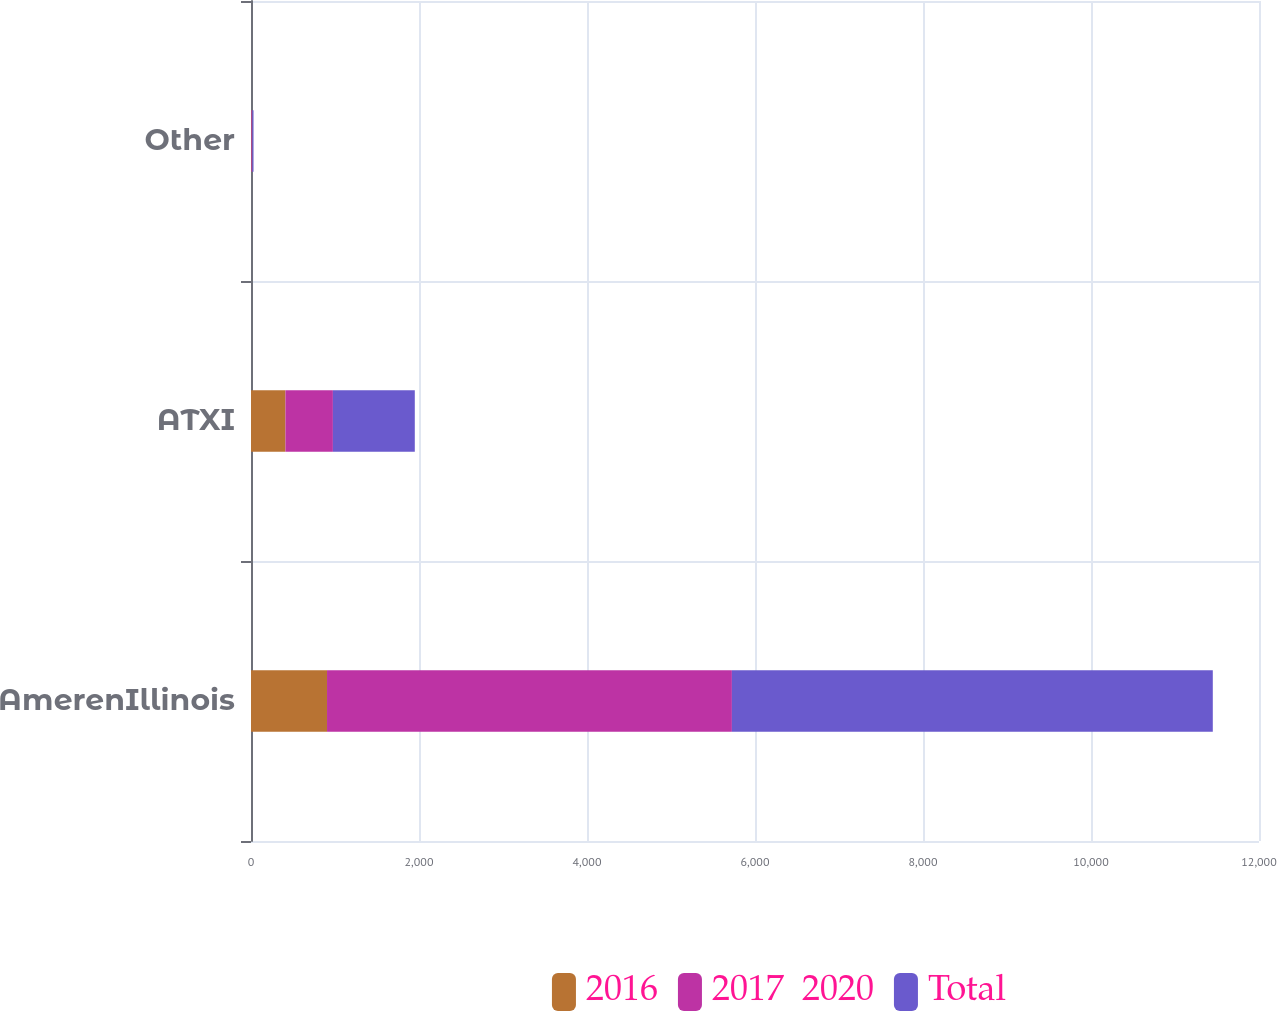Convert chart. <chart><loc_0><loc_0><loc_500><loc_500><stacked_bar_chart><ecel><fcel>AmerenIllinois<fcel>ATXI<fcel>Other<nl><fcel>2016<fcel>905<fcel>410<fcel>5<nl><fcel>2017  2020<fcel>4820<fcel>565<fcel>10<nl><fcel>Total<fcel>5725<fcel>975<fcel>15<nl></chart> 